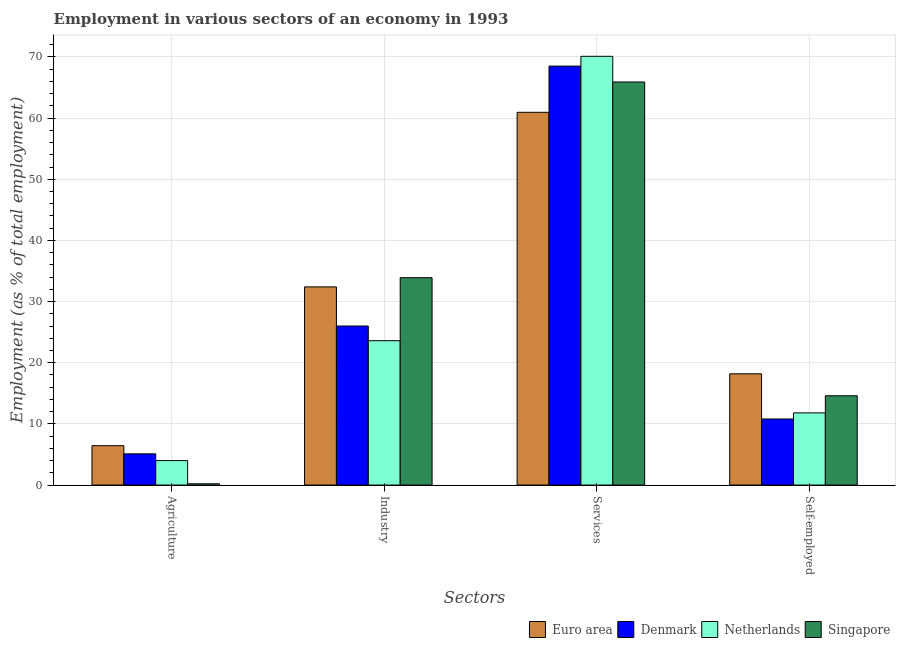How many different coloured bars are there?
Give a very brief answer. 4. How many groups of bars are there?
Offer a terse response. 4. What is the label of the 1st group of bars from the left?
Offer a terse response. Agriculture. What is the percentage of workers in industry in Euro area?
Provide a short and direct response. 32.4. Across all countries, what is the maximum percentage of workers in industry?
Ensure brevity in your answer.  33.9. Across all countries, what is the minimum percentage of workers in agriculture?
Make the answer very short. 0.2. In which country was the percentage of workers in industry maximum?
Your response must be concise. Singapore. In which country was the percentage of workers in agriculture minimum?
Offer a very short reply. Singapore. What is the total percentage of workers in agriculture in the graph?
Your response must be concise. 15.74. What is the difference between the percentage of workers in agriculture in Denmark and that in Euro area?
Your answer should be very brief. -1.34. What is the difference between the percentage of workers in services in Euro area and the percentage of self employed workers in Singapore?
Make the answer very short. 46.35. What is the average percentage of workers in services per country?
Offer a very short reply. 66.36. What is the difference between the percentage of workers in industry and percentage of workers in services in Denmark?
Provide a succinct answer. -42.5. What is the ratio of the percentage of workers in industry in Euro area to that in Denmark?
Your answer should be very brief. 1.25. Is the difference between the percentage of workers in services in Denmark and Netherlands greater than the difference between the percentage of self employed workers in Denmark and Netherlands?
Your response must be concise. No. What is the difference between the highest and the second highest percentage of workers in industry?
Your answer should be very brief. 1.5. What is the difference between the highest and the lowest percentage of workers in services?
Give a very brief answer. 9.15. Is the sum of the percentage of workers in industry in Singapore and Euro area greater than the maximum percentage of workers in agriculture across all countries?
Provide a succinct answer. Yes. What does the 4th bar from the left in Services represents?
Keep it short and to the point. Singapore. What does the 2nd bar from the right in Self-employed represents?
Your answer should be compact. Netherlands. Are all the bars in the graph horizontal?
Provide a short and direct response. No. What is the difference between two consecutive major ticks on the Y-axis?
Make the answer very short. 10. Are the values on the major ticks of Y-axis written in scientific E-notation?
Your answer should be compact. No. Does the graph contain grids?
Offer a very short reply. Yes. Where does the legend appear in the graph?
Provide a short and direct response. Bottom right. What is the title of the graph?
Your answer should be compact. Employment in various sectors of an economy in 1993. Does "Mongolia" appear as one of the legend labels in the graph?
Offer a very short reply. No. What is the label or title of the X-axis?
Give a very brief answer. Sectors. What is the label or title of the Y-axis?
Keep it short and to the point. Employment (as % of total employment). What is the Employment (as % of total employment) of Euro area in Agriculture?
Offer a terse response. 6.44. What is the Employment (as % of total employment) of Denmark in Agriculture?
Keep it short and to the point. 5.1. What is the Employment (as % of total employment) of Netherlands in Agriculture?
Keep it short and to the point. 4. What is the Employment (as % of total employment) of Singapore in Agriculture?
Give a very brief answer. 0.2. What is the Employment (as % of total employment) of Euro area in Industry?
Ensure brevity in your answer.  32.4. What is the Employment (as % of total employment) in Denmark in Industry?
Offer a terse response. 26. What is the Employment (as % of total employment) of Netherlands in Industry?
Give a very brief answer. 23.6. What is the Employment (as % of total employment) of Singapore in Industry?
Provide a succinct answer. 33.9. What is the Employment (as % of total employment) of Euro area in Services?
Your answer should be compact. 60.95. What is the Employment (as % of total employment) of Denmark in Services?
Provide a short and direct response. 68.5. What is the Employment (as % of total employment) of Netherlands in Services?
Your answer should be very brief. 70.1. What is the Employment (as % of total employment) in Singapore in Services?
Keep it short and to the point. 65.9. What is the Employment (as % of total employment) of Euro area in Self-employed?
Offer a terse response. 18.19. What is the Employment (as % of total employment) in Denmark in Self-employed?
Your answer should be compact. 10.8. What is the Employment (as % of total employment) in Netherlands in Self-employed?
Your response must be concise. 11.8. What is the Employment (as % of total employment) of Singapore in Self-employed?
Your answer should be very brief. 14.6. Across all Sectors, what is the maximum Employment (as % of total employment) in Euro area?
Offer a very short reply. 60.95. Across all Sectors, what is the maximum Employment (as % of total employment) in Denmark?
Make the answer very short. 68.5. Across all Sectors, what is the maximum Employment (as % of total employment) in Netherlands?
Provide a short and direct response. 70.1. Across all Sectors, what is the maximum Employment (as % of total employment) of Singapore?
Keep it short and to the point. 65.9. Across all Sectors, what is the minimum Employment (as % of total employment) of Euro area?
Provide a short and direct response. 6.44. Across all Sectors, what is the minimum Employment (as % of total employment) in Denmark?
Offer a very short reply. 5.1. Across all Sectors, what is the minimum Employment (as % of total employment) in Netherlands?
Your answer should be very brief. 4. Across all Sectors, what is the minimum Employment (as % of total employment) of Singapore?
Your answer should be very brief. 0.2. What is the total Employment (as % of total employment) in Euro area in the graph?
Your answer should be very brief. 117.97. What is the total Employment (as % of total employment) in Denmark in the graph?
Keep it short and to the point. 110.4. What is the total Employment (as % of total employment) in Netherlands in the graph?
Provide a succinct answer. 109.5. What is the total Employment (as % of total employment) in Singapore in the graph?
Your response must be concise. 114.6. What is the difference between the Employment (as % of total employment) in Euro area in Agriculture and that in Industry?
Ensure brevity in your answer.  -25.96. What is the difference between the Employment (as % of total employment) in Denmark in Agriculture and that in Industry?
Provide a short and direct response. -20.9. What is the difference between the Employment (as % of total employment) of Netherlands in Agriculture and that in Industry?
Give a very brief answer. -19.6. What is the difference between the Employment (as % of total employment) in Singapore in Agriculture and that in Industry?
Give a very brief answer. -33.7. What is the difference between the Employment (as % of total employment) of Euro area in Agriculture and that in Services?
Keep it short and to the point. -54.51. What is the difference between the Employment (as % of total employment) in Denmark in Agriculture and that in Services?
Provide a short and direct response. -63.4. What is the difference between the Employment (as % of total employment) of Netherlands in Agriculture and that in Services?
Provide a succinct answer. -66.1. What is the difference between the Employment (as % of total employment) of Singapore in Agriculture and that in Services?
Give a very brief answer. -65.7. What is the difference between the Employment (as % of total employment) of Euro area in Agriculture and that in Self-employed?
Your answer should be very brief. -11.75. What is the difference between the Employment (as % of total employment) in Singapore in Agriculture and that in Self-employed?
Offer a very short reply. -14.4. What is the difference between the Employment (as % of total employment) of Euro area in Industry and that in Services?
Offer a very short reply. -28.55. What is the difference between the Employment (as % of total employment) of Denmark in Industry and that in Services?
Your answer should be very brief. -42.5. What is the difference between the Employment (as % of total employment) of Netherlands in Industry and that in Services?
Provide a short and direct response. -46.5. What is the difference between the Employment (as % of total employment) in Singapore in Industry and that in Services?
Keep it short and to the point. -32. What is the difference between the Employment (as % of total employment) of Euro area in Industry and that in Self-employed?
Provide a succinct answer. 14.21. What is the difference between the Employment (as % of total employment) in Denmark in Industry and that in Self-employed?
Make the answer very short. 15.2. What is the difference between the Employment (as % of total employment) of Singapore in Industry and that in Self-employed?
Keep it short and to the point. 19.3. What is the difference between the Employment (as % of total employment) in Euro area in Services and that in Self-employed?
Provide a succinct answer. 42.76. What is the difference between the Employment (as % of total employment) of Denmark in Services and that in Self-employed?
Provide a short and direct response. 57.7. What is the difference between the Employment (as % of total employment) in Netherlands in Services and that in Self-employed?
Make the answer very short. 58.3. What is the difference between the Employment (as % of total employment) of Singapore in Services and that in Self-employed?
Your answer should be compact. 51.3. What is the difference between the Employment (as % of total employment) of Euro area in Agriculture and the Employment (as % of total employment) of Denmark in Industry?
Keep it short and to the point. -19.56. What is the difference between the Employment (as % of total employment) of Euro area in Agriculture and the Employment (as % of total employment) of Netherlands in Industry?
Your response must be concise. -17.16. What is the difference between the Employment (as % of total employment) of Euro area in Agriculture and the Employment (as % of total employment) of Singapore in Industry?
Ensure brevity in your answer.  -27.46. What is the difference between the Employment (as % of total employment) in Denmark in Agriculture and the Employment (as % of total employment) in Netherlands in Industry?
Give a very brief answer. -18.5. What is the difference between the Employment (as % of total employment) of Denmark in Agriculture and the Employment (as % of total employment) of Singapore in Industry?
Ensure brevity in your answer.  -28.8. What is the difference between the Employment (as % of total employment) of Netherlands in Agriculture and the Employment (as % of total employment) of Singapore in Industry?
Give a very brief answer. -29.9. What is the difference between the Employment (as % of total employment) of Euro area in Agriculture and the Employment (as % of total employment) of Denmark in Services?
Provide a succinct answer. -62.06. What is the difference between the Employment (as % of total employment) in Euro area in Agriculture and the Employment (as % of total employment) in Netherlands in Services?
Offer a very short reply. -63.66. What is the difference between the Employment (as % of total employment) of Euro area in Agriculture and the Employment (as % of total employment) of Singapore in Services?
Offer a terse response. -59.46. What is the difference between the Employment (as % of total employment) of Denmark in Agriculture and the Employment (as % of total employment) of Netherlands in Services?
Keep it short and to the point. -65. What is the difference between the Employment (as % of total employment) in Denmark in Agriculture and the Employment (as % of total employment) in Singapore in Services?
Offer a terse response. -60.8. What is the difference between the Employment (as % of total employment) in Netherlands in Agriculture and the Employment (as % of total employment) in Singapore in Services?
Your answer should be compact. -61.9. What is the difference between the Employment (as % of total employment) in Euro area in Agriculture and the Employment (as % of total employment) in Denmark in Self-employed?
Make the answer very short. -4.36. What is the difference between the Employment (as % of total employment) of Euro area in Agriculture and the Employment (as % of total employment) of Netherlands in Self-employed?
Your answer should be very brief. -5.36. What is the difference between the Employment (as % of total employment) in Euro area in Agriculture and the Employment (as % of total employment) in Singapore in Self-employed?
Provide a succinct answer. -8.16. What is the difference between the Employment (as % of total employment) of Denmark in Agriculture and the Employment (as % of total employment) of Singapore in Self-employed?
Keep it short and to the point. -9.5. What is the difference between the Employment (as % of total employment) of Euro area in Industry and the Employment (as % of total employment) of Denmark in Services?
Your response must be concise. -36.1. What is the difference between the Employment (as % of total employment) of Euro area in Industry and the Employment (as % of total employment) of Netherlands in Services?
Offer a very short reply. -37.7. What is the difference between the Employment (as % of total employment) in Euro area in Industry and the Employment (as % of total employment) in Singapore in Services?
Ensure brevity in your answer.  -33.5. What is the difference between the Employment (as % of total employment) of Denmark in Industry and the Employment (as % of total employment) of Netherlands in Services?
Ensure brevity in your answer.  -44.1. What is the difference between the Employment (as % of total employment) of Denmark in Industry and the Employment (as % of total employment) of Singapore in Services?
Offer a terse response. -39.9. What is the difference between the Employment (as % of total employment) in Netherlands in Industry and the Employment (as % of total employment) in Singapore in Services?
Your response must be concise. -42.3. What is the difference between the Employment (as % of total employment) in Euro area in Industry and the Employment (as % of total employment) in Denmark in Self-employed?
Provide a short and direct response. 21.6. What is the difference between the Employment (as % of total employment) in Euro area in Industry and the Employment (as % of total employment) in Netherlands in Self-employed?
Make the answer very short. 20.6. What is the difference between the Employment (as % of total employment) in Euro area in Industry and the Employment (as % of total employment) in Singapore in Self-employed?
Your answer should be compact. 17.8. What is the difference between the Employment (as % of total employment) of Denmark in Industry and the Employment (as % of total employment) of Netherlands in Self-employed?
Your answer should be very brief. 14.2. What is the difference between the Employment (as % of total employment) of Denmark in Industry and the Employment (as % of total employment) of Singapore in Self-employed?
Offer a terse response. 11.4. What is the difference between the Employment (as % of total employment) in Netherlands in Industry and the Employment (as % of total employment) in Singapore in Self-employed?
Make the answer very short. 9. What is the difference between the Employment (as % of total employment) in Euro area in Services and the Employment (as % of total employment) in Denmark in Self-employed?
Your answer should be very brief. 50.15. What is the difference between the Employment (as % of total employment) of Euro area in Services and the Employment (as % of total employment) of Netherlands in Self-employed?
Ensure brevity in your answer.  49.15. What is the difference between the Employment (as % of total employment) of Euro area in Services and the Employment (as % of total employment) of Singapore in Self-employed?
Offer a very short reply. 46.35. What is the difference between the Employment (as % of total employment) in Denmark in Services and the Employment (as % of total employment) in Netherlands in Self-employed?
Provide a short and direct response. 56.7. What is the difference between the Employment (as % of total employment) of Denmark in Services and the Employment (as % of total employment) of Singapore in Self-employed?
Offer a terse response. 53.9. What is the difference between the Employment (as % of total employment) in Netherlands in Services and the Employment (as % of total employment) in Singapore in Self-employed?
Offer a terse response. 55.5. What is the average Employment (as % of total employment) of Euro area per Sectors?
Give a very brief answer. 29.49. What is the average Employment (as % of total employment) in Denmark per Sectors?
Your response must be concise. 27.6. What is the average Employment (as % of total employment) in Netherlands per Sectors?
Keep it short and to the point. 27.38. What is the average Employment (as % of total employment) of Singapore per Sectors?
Offer a very short reply. 28.65. What is the difference between the Employment (as % of total employment) of Euro area and Employment (as % of total employment) of Denmark in Agriculture?
Your response must be concise. 1.34. What is the difference between the Employment (as % of total employment) in Euro area and Employment (as % of total employment) in Netherlands in Agriculture?
Offer a terse response. 2.44. What is the difference between the Employment (as % of total employment) of Euro area and Employment (as % of total employment) of Singapore in Agriculture?
Your response must be concise. 6.24. What is the difference between the Employment (as % of total employment) in Netherlands and Employment (as % of total employment) in Singapore in Agriculture?
Give a very brief answer. 3.8. What is the difference between the Employment (as % of total employment) in Euro area and Employment (as % of total employment) in Denmark in Industry?
Give a very brief answer. 6.4. What is the difference between the Employment (as % of total employment) in Euro area and Employment (as % of total employment) in Netherlands in Industry?
Make the answer very short. 8.8. What is the difference between the Employment (as % of total employment) of Euro area and Employment (as % of total employment) of Singapore in Industry?
Provide a short and direct response. -1.5. What is the difference between the Employment (as % of total employment) in Denmark and Employment (as % of total employment) in Netherlands in Industry?
Keep it short and to the point. 2.4. What is the difference between the Employment (as % of total employment) of Netherlands and Employment (as % of total employment) of Singapore in Industry?
Your response must be concise. -10.3. What is the difference between the Employment (as % of total employment) in Euro area and Employment (as % of total employment) in Denmark in Services?
Provide a short and direct response. -7.55. What is the difference between the Employment (as % of total employment) of Euro area and Employment (as % of total employment) of Netherlands in Services?
Offer a terse response. -9.15. What is the difference between the Employment (as % of total employment) of Euro area and Employment (as % of total employment) of Singapore in Services?
Give a very brief answer. -4.95. What is the difference between the Employment (as % of total employment) of Denmark and Employment (as % of total employment) of Singapore in Services?
Provide a short and direct response. 2.6. What is the difference between the Employment (as % of total employment) of Euro area and Employment (as % of total employment) of Denmark in Self-employed?
Provide a short and direct response. 7.39. What is the difference between the Employment (as % of total employment) in Euro area and Employment (as % of total employment) in Netherlands in Self-employed?
Ensure brevity in your answer.  6.39. What is the difference between the Employment (as % of total employment) of Euro area and Employment (as % of total employment) of Singapore in Self-employed?
Ensure brevity in your answer.  3.59. What is the difference between the Employment (as % of total employment) in Denmark and Employment (as % of total employment) in Netherlands in Self-employed?
Provide a short and direct response. -1. What is the difference between the Employment (as % of total employment) in Netherlands and Employment (as % of total employment) in Singapore in Self-employed?
Your answer should be compact. -2.8. What is the ratio of the Employment (as % of total employment) in Euro area in Agriculture to that in Industry?
Ensure brevity in your answer.  0.2. What is the ratio of the Employment (as % of total employment) of Denmark in Agriculture to that in Industry?
Offer a very short reply. 0.2. What is the ratio of the Employment (as % of total employment) in Netherlands in Agriculture to that in Industry?
Make the answer very short. 0.17. What is the ratio of the Employment (as % of total employment) in Singapore in Agriculture to that in Industry?
Make the answer very short. 0.01. What is the ratio of the Employment (as % of total employment) of Euro area in Agriculture to that in Services?
Your answer should be very brief. 0.11. What is the ratio of the Employment (as % of total employment) in Denmark in Agriculture to that in Services?
Give a very brief answer. 0.07. What is the ratio of the Employment (as % of total employment) of Netherlands in Agriculture to that in Services?
Provide a short and direct response. 0.06. What is the ratio of the Employment (as % of total employment) in Singapore in Agriculture to that in Services?
Your answer should be compact. 0. What is the ratio of the Employment (as % of total employment) of Euro area in Agriculture to that in Self-employed?
Your answer should be compact. 0.35. What is the ratio of the Employment (as % of total employment) of Denmark in Agriculture to that in Self-employed?
Keep it short and to the point. 0.47. What is the ratio of the Employment (as % of total employment) of Netherlands in Agriculture to that in Self-employed?
Offer a terse response. 0.34. What is the ratio of the Employment (as % of total employment) in Singapore in Agriculture to that in Self-employed?
Keep it short and to the point. 0.01. What is the ratio of the Employment (as % of total employment) of Euro area in Industry to that in Services?
Your answer should be compact. 0.53. What is the ratio of the Employment (as % of total employment) in Denmark in Industry to that in Services?
Your answer should be very brief. 0.38. What is the ratio of the Employment (as % of total employment) in Netherlands in Industry to that in Services?
Offer a very short reply. 0.34. What is the ratio of the Employment (as % of total employment) of Singapore in Industry to that in Services?
Offer a very short reply. 0.51. What is the ratio of the Employment (as % of total employment) in Euro area in Industry to that in Self-employed?
Your response must be concise. 1.78. What is the ratio of the Employment (as % of total employment) of Denmark in Industry to that in Self-employed?
Provide a short and direct response. 2.41. What is the ratio of the Employment (as % of total employment) of Singapore in Industry to that in Self-employed?
Your answer should be very brief. 2.32. What is the ratio of the Employment (as % of total employment) of Euro area in Services to that in Self-employed?
Ensure brevity in your answer.  3.35. What is the ratio of the Employment (as % of total employment) in Denmark in Services to that in Self-employed?
Ensure brevity in your answer.  6.34. What is the ratio of the Employment (as % of total employment) of Netherlands in Services to that in Self-employed?
Ensure brevity in your answer.  5.94. What is the ratio of the Employment (as % of total employment) of Singapore in Services to that in Self-employed?
Your response must be concise. 4.51. What is the difference between the highest and the second highest Employment (as % of total employment) of Euro area?
Your response must be concise. 28.55. What is the difference between the highest and the second highest Employment (as % of total employment) in Denmark?
Ensure brevity in your answer.  42.5. What is the difference between the highest and the second highest Employment (as % of total employment) of Netherlands?
Give a very brief answer. 46.5. What is the difference between the highest and the lowest Employment (as % of total employment) of Euro area?
Your answer should be very brief. 54.51. What is the difference between the highest and the lowest Employment (as % of total employment) of Denmark?
Your response must be concise. 63.4. What is the difference between the highest and the lowest Employment (as % of total employment) of Netherlands?
Provide a succinct answer. 66.1. What is the difference between the highest and the lowest Employment (as % of total employment) of Singapore?
Your answer should be very brief. 65.7. 